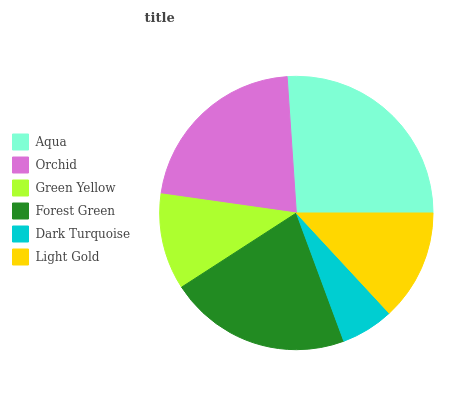Is Dark Turquoise the minimum?
Answer yes or no. Yes. Is Aqua the maximum?
Answer yes or no. Yes. Is Orchid the minimum?
Answer yes or no. No. Is Orchid the maximum?
Answer yes or no. No. Is Aqua greater than Orchid?
Answer yes or no. Yes. Is Orchid less than Aqua?
Answer yes or no. Yes. Is Orchid greater than Aqua?
Answer yes or no. No. Is Aqua less than Orchid?
Answer yes or no. No. Is Forest Green the high median?
Answer yes or no. Yes. Is Light Gold the low median?
Answer yes or no. Yes. Is Orchid the high median?
Answer yes or no. No. Is Dark Turquoise the low median?
Answer yes or no. No. 